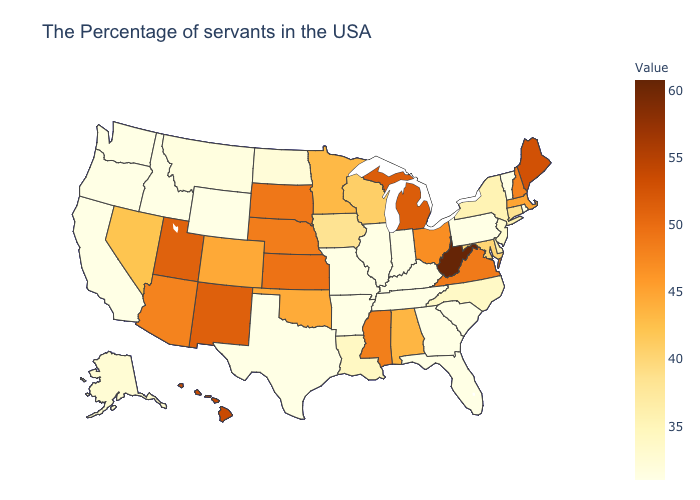Among the states that border Missouri , does Kansas have the highest value?
Write a very short answer. Yes. Does Mississippi have a lower value than Minnesota?
Give a very brief answer. No. Which states have the lowest value in the South?
Answer briefly. South Carolina, Florida, Georgia, Kentucky, Tennessee, Arkansas, Texas. Which states have the lowest value in the USA?
Answer briefly. Rhode Island, Vermont, Pennsylvania, South Carolina, Florida, Georgia, Kentucky, Indiana, Tennessee, Illinois, Missouri, Arkansas, Texas, Wyoming, Idaho, California, Washington, Oregon. Among the states that border New York , which have the highest value?
Quick response, please. Massachusetts. Does Michigan have the highest value in the MidWest?
Give a very brief answer. Yes. 